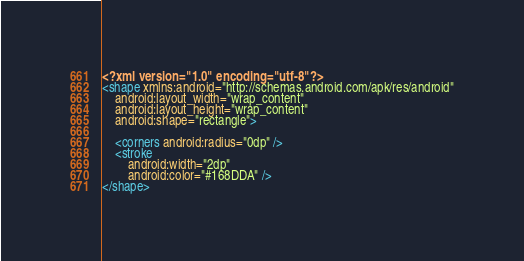Convert code to text. <code><loc_0><loc_0><loc_500><loc_500><_XML_><?xml version="1.0" encoding="utf-8"?>
<shape xmlns:android="http://schemas.android.com/apk/res/android"
    android:layout_width="wrap_content"
    android:layout_height="wrap_content"
    android:shape="rectangle">

    <corners android:radius="0dp" />
    <stroke
        android:width="2dp"
        android:color="#168DDA" />
</shape></code> 